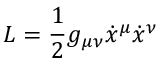<formula> <loc_0><loc_0><loc_500><loc_500>L = \frac { 1 } { 2 } g _ { \mu \nu } \dot { x } ^ { \mu } \dot { x } ^ { \nu }</formula> 